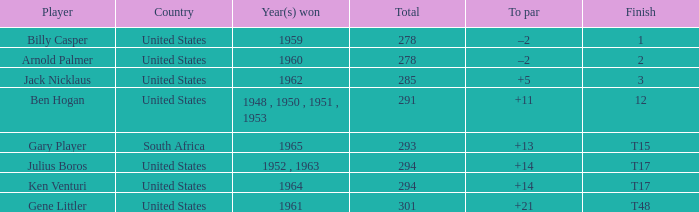Would you mind parsing the complete table? {'header': ['Player', 'Country', 'Year(s) won', 'Total', 'To par', 'Finish'], 'rows': [['Billy Casper', 'United States', '1959', '278', '–2', '1'], ['Arnold Palmer', 'United States', '1960', '278', '–2', '2'], ['Jack Nicklaus', 'United States', '1962', '285', '+5', '3'], ['Ben Hogan', 'United States', '1948 , 1950 , 1951 , 1953', '291', '+11', '12'], ['Gary Player', 'South Africa', '1965', '293', '+13', 'T15'], ['Julius Boros', 'United States', '1952 , 1963', '294', '+14', 'T17'], ['Ken Venturi', 'United States', '1964', '294', '+14', 'T17'], ['Gene Littler', 'United States', '1961', '301', '+21', 'T48']]} What is Year(s) Won, when Total is less than 285? 1959, 1960. 